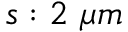Convert formula to latex. <formula><loc_0><loc_0><loc_500><loc_500>s \colon 2 \ \mu m</formula> 